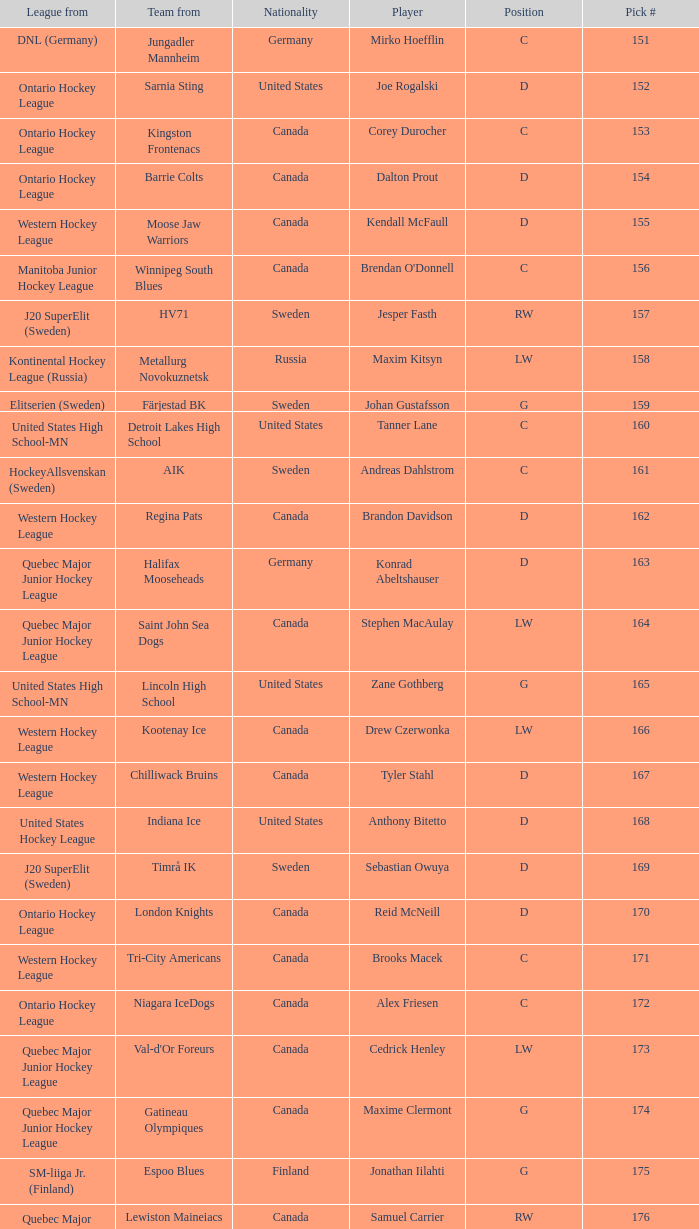What is the position of the team player from Aik? C. Parse the full table. {'header': ['League from', 'Team from', 'Nationality', 'Player', 'Position', 'Pick #'], 'rows': [['DNL (Germany)', 'Jungadler Mannheim', 'Germany', 'Mirko Hoefflin', 'C', '151'], ['Ontario Hockey League', 'Sarnia Sting', 'United States', 'Joe Rogalski', 'D', '152'], ['Ontario Hockey League', 'Kingston Frontenacs', 'Canada', 'Corey Durocher', 'C', '153'], ['Ontario Hockey League', 'Barrie Colts', 'Canada', 'Dalton Prout', 'D', '154'], ['Western Hockey League', 'Moose Jaw Warriors', 'Canada', 'Kendall McFaull', 'D', '155'], ['Manitoba Junior Hockey League', 'Winnipeg South Blues', 'Canada', "Brendan O'Donnell", 'C', '156'], ['J20 SuperElit (Sweden)', 'HV71', 'Sweden', 'Jesper Fasth', 'RW', '157'], ['Kontinental Hockey League (Russia)', 'Metallurg Novokuznetsk', 'Russia', 'Maxim Kitsyn', 'LW', '158'], ['Elitserien (Sweden)', 'Färjestad BK', 'Sweden', 'Johan Gustafsson', 'G', '159'], ['United States High School-MN', 'Detroit Lakes High School', 'United States', 'Tanner Lane', 'C', '160'], ['HockeyAllsvenskan (Sweden)', 'AIK', 'Sweden', 'Andreas Dahlstrom', 'C', '161'], ['Western Hockey League', 'Regina Pats', 'Canada', 'Brandon Davidson', 'D', '162'], ['Quebec Major Junior Hockey League', 'Halifax Mooseheads', 'Germany', 'Konrad Abeltshauser', 'D', '163'], ['Quebec Major Junior Hockey League', 'Saint John Sea Dogs', 'Canada', 'Stephen MacAulay', 'LW', '164'], ['United States High School-MN', 'Lincoln High School', 'United States', 'Zane Gothberg', 'G', '165'], ['Western Hockey League', 'Kootenay Ice', 'Canada', 'Drew Czerwonka', 'LW', '166'], ['Western Hockey League', 'Chilliwack Bruins', 'Canada', 'Tyler Stahl', 'D', '167'], ['United States Hockey League', 'Indiana Ice', 'United States', 'Anthony Bitetto', 'D', '168'], ['J20 SuperElit (Sweden)', 'Timrå IK', 'Sweden', 'Sebastian Owuya', 'D', '169'], ['Ontario Hockey League', 'London Knights', 'Canada', 'Reid McNeill', 'D', '170'], ['Western Hockey League', 'Tri-City Americans', 'Canada', 'Brooks Macek', 'C', '171'], ['Ontario Hockey League', 'Niagara IceDogs', 'Canada', 'Alex Friesen', 'C', '172'], ['Quebec Major Junior Hockey League', "Val-d'Or Foreurs", 'Canada', 'Cedrick Henley', 'LW', '173'], ['Quebec Major Junior Hockey League', 'Gatineau Olympiques', 'Canada', 'Maxime Clermont', 'G', '174'], ['SM-liiga Jr. (Finland)', 'Espoo Blues', 'Finland', 'Jonathan Iilahti', 'G', '175'], ['Quebec Major Junior Hockey League', 'Lewiston Maineiacs', 'Canada', 'Samuel Carrier', 'RW', '176'], ['United States Hockey League', 'Chicago Steel', 'United States', 'Kevin Lind', 'D', '177'], ['Western Hockey League', 'Brandon Wheat Kings', 'Canada', 'Mark Stone', 'RW', '178'], ['United States High School-CT', 'The Gunnery', 'United States', 'Nicholas Luukko', 'D', '179'], ['United States Hockey League', 'Indiana Ice', 'United States', 'Nick Mattson', 'D', '180']]} 